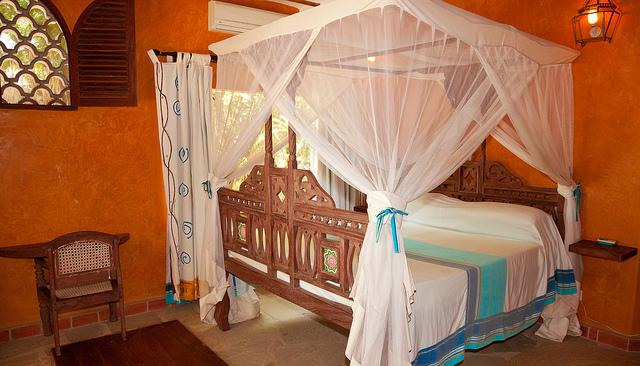The walls are most likely covered in what material? Please explain your reasoning. plaster. The walls have plaster on them. 